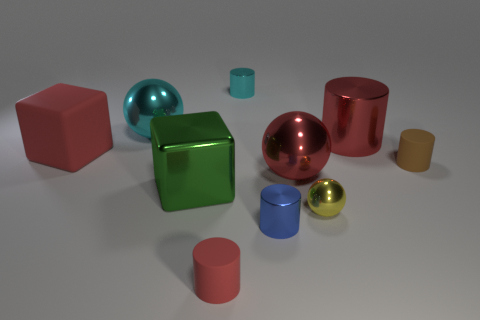How many red cylinders must be subtracted to get 1 red cylinders? 1 Subtract all cyan balls. How many balls are left? 2 Subtract 1 blue cylinders. How many objects are left? 9 Subtract all spheres. How many objects are left? 7 Subtract 3 cylinders. How many cylinders are left? 2 Subtract all purple blocks. Subtract all green spheres. How many blocks are left? 2 Subtract all blue spheres. How many green cubes are left? 1 Subtract all small blue matte objects. Subtract all matte objects. How many objects are left? 7 Add 6 tiny spheres. How many tiny spheres are left? 7 Add 4 green blocks. How many green blocks exist? 5 